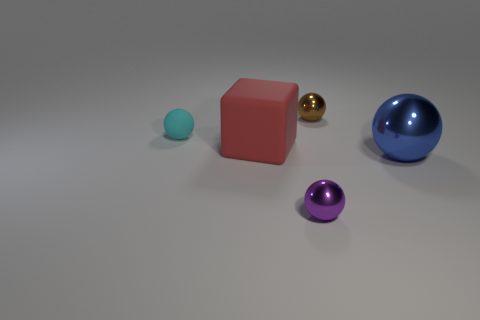How many cubes are large metallic objects or large objects?
Offer a very short reply. 1. There is a small object left of the sphere in front of the big blue metallic ball; how many small things are behind it?
Provide a succinct answer. 1. What color is the metallic ball that is the same size as the brown metal object?
Give a very brief answer. Purple. Are there more big blue spheres that are on the left side of the tiny purple ball than tiny metal things?
Ensure brevity in your answer.  No. Are the cyan object and the brown ball made of the same material?
Provide a succinct answer. No. How many things are either large objects that are left of the tiny brown object or tiny spheres?
Your answer should be very brief. 4. How many other objects are the same size as the cyan thing?
Provide a succinct answer. 2. Are there the same number of tiny metal spheres to the right of the purple metal ball and big red objects that are in front of the big cube?
Provide a short and direct response. No. What is the color of the matte object that is the same shape as the blue shiny thing?
Offer a very short reply. Cyan. Is there any other thing that is the same shape as the small rubber object?
Keep it short and to the point. Yes. 